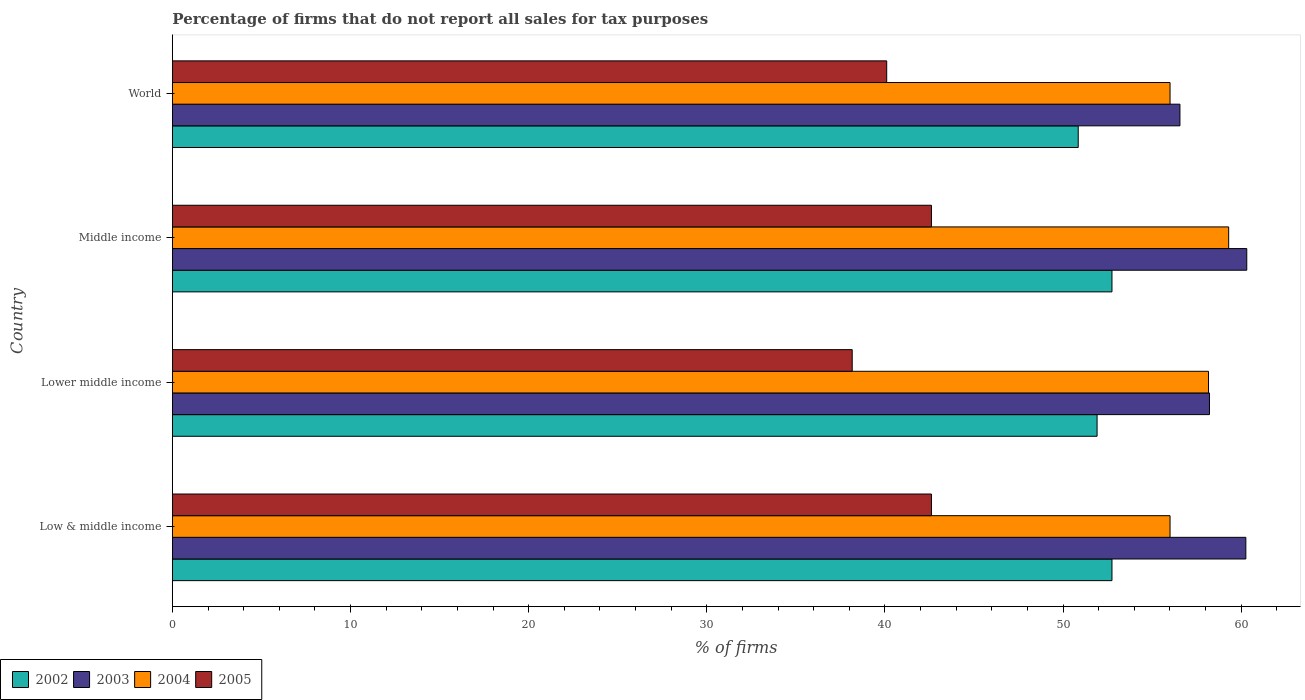Are the number of bars on each tick of the Y-axis equal?
Ensure brevity in your answer.  Yes. How many bars are there on the 2nd tick from the top?
Offer a very short reply. 4. In how many cases, is the number of bars for a given country not equal to the number of legend labels?
Provide a succinct answer. 0. What is the percentage of firms that do not report all sales for tax purposes in 2003 in Middle income?
Make the answer very short. 60.31. Across all countries, what is the maximum percentage of firms that do not report all sales for tax purposes in 2004?
Give a very brief answer. 59.3. Across all countries, what is the minimum percentage of firms that do not report all sales for tax purposes in 2003?
Keep it short and to the point. 56.56. In which country was the percentage of firms that do not report all sales for tax purposes in 2003 maximum?
Provide a short and direct response. Middle income. In which country was the percentage of firms that do not report all sales for tax purposes in 2003 minimum?
Offer a terse response. World. What is the total percentage of firms that do not report all sales for tax purposes in 2002 in the graph?
Keep it short and to the point. 208.25. What is the difference between the percentage of firms that do not report all sales for tax purposes in 2005 in Low & middle income and that in Lower middle income?
Make the answer very short. 4.45. What is the difference between the percentage of firms that do not report all sales for tax purposes in 2004 in Middle income and the percentage of firms that do not report all sales for tax purposes in 2003 in World?
Keep it short and to the point. 2.74. What is the average percentage of firms that do not report all sales for tax purposes in 2004 per country?
Your answer should be compact. 57.37. What is the difference between the percentage of firms that do not report all sales for tax purposes in 2003 and percentage of firms that do not report all sales for tax purposes in 2002 in Lower middle income?
Offer a very short reply. 6.31. In how many countries, is the percentage of firms that do not report all sales for tax purposes in 2004 greater than 34 %?
Give a very brief answer. 4. What is the ratio of the percentage of firms that do not report all sales for tax purposes in 2003 in Lower middle income to that in World?
Give a very brief answer. 1.03. Is the percentage of firms that do not report all sales for tax purposes in 2003 in Lower middle income less than that in World?
Your response must be concise. No. Is the difference between the percentage of firms that do not report all sales for tax purposes in 2003 in Low & middle income and Middle income greater than the difference between the percentage of firms that do not report all sales for tax purposes in 2002 in Low & middle income and Middle income?
Provide a succinct answer. No. What is the difference between the highest and the second highest percentage of firms that do not report all sales for tax purposes in 2005?
Offer a very short reply. 0. What is the difference between the highest and the lowest percentage of firms that do not report all sales for tax purposes in 2004?
Keep it short and to the point. 3.29. Is it the case that in every country, the sum of the percentage of firms that do not report all sales for tax purposes in 2004 and percentage of firms that do not report all sales for tax purposes in 2005 is greater than the sum of percentage of firms that do not report all sales for tax purposes in 2002 and percentage of firms that do not report all sales for tax purposes in 2003?
Make the answer very short. No. What does the 3rd bar from the top in Low & middle income represents?
Keep it short and to the point. 2003. Is it the case that in every country, the sum of the percentage of firms that do not report all sales for tax purposes in 2005 and percentage of firms that do not report all sales for tax purposes in 2004 is greater than the percentage of firms that do not report all sales for tax purposes in 2002?
Ensure brevity in your answer.  Yes. How many countries are there in the graph?
Your answer should be compact. 4. How many legend labels are there?
Keep it short and to the point. 4. What is the title of the graph?
Your answer should be compact. Percentage of firms that do not report all sales for tax purposes. Does "1998" appear as one of the legend labels in the graph?
Give a very brief answer. No. What is the label or title of the X-axis?
Offer a terse response. % of firms. What is the % of firms in 2002 in Low & middle income?
Ensure brevity in your answer.  52.75. What is the % of firms in 2003 in Low & middle income?
Your answer should be very brief. 60.26. What is the % of firms in 2004 in Low & middle income?
Ensure brevity in your answer.  56.01. What is the % of firms in 2005 in Low & middle income?
Offer a very short reply. 42.61. What is the % of firms of 2002 in Lower middle income?
Provide a short and direct response. 51.91. What is the % of firms of 2003 in Lower middle income?
Your answer should be very brief. 58.22. What is the % of firms in 2004 in Lower middle income?
Offer a terse response. 58.16. What is the % of firms in 2005 in Lower middle income?
Make the answer very short. 38.16. What is the % of firms of 2002 in Middle income?
Offer a very short reply. 52.75. What is the % of firms of 2003 in Middle income?
Give a very brief answer. 60.31. What is the % of firms in 2004 in Middle income?
Provide a succinct answer. 59.3. What is the % of firms in 2005 in Middle income?
Your answer should be very brief. 42.61. What is the % of firms of 2002 in World?
Offer a very short reply. 50.85. What is the % of firms of 2003 in World?
Give a very brief answer. 56.56. What is the % of firms in 2004 in World?
Your answer should be compact. 56.01. What is the % of firms of 2005 in World?
Your answer should be compact. 40.1. Across all countries, what is the maximum % of firms in 2002?
Your response must be concise. 52.75. Across all countries, what is the maximum % of firms in 2003?
Ensure brevity in your answer.  60.31. Across all countries, what is the maximum % of firms in 2004?
Your response must be concise. 59.3. Across all countries, what is the maximum % of firms of 2005?
Offer a very short reply. 42.61. Across all countries, what is the minimum % of firms in 2002?
Provide a short and direct response. 50.85. Across all countries, what is the minimum % of firms of 2003?
Offer a terse response. 56.56. Across all countries, what is the minimum % of firms of 2004?
Provide a short and direct response. 56.01. Across all countries, what is the minimum % of firms of 2005?
Your answer should be compact. 38.16. What is the total % of firms of 2002 in the graph?
Make the answer very short. 208.25. What is the total % of firms of 2003 in the graph?
Your answer should be compact. 235.35. What is the total % of firms in 2004 in the graph?
Your answer should be compact. 229.47. What is the total % of firms in 2005 in the graph?
Your response must be concise. 163.48. What is the difference between the % of firms of 2002 in Low & middle income and that in Lower middle income?
Your response must be concise. 0.84. What is the difference between the % of firms in 2003 in Low & middle income and that in Lower middle income?
Give a very brief answer. 2.04. What is the difference between the % of firms of 2004 in Low & middle income and that in Lower middle income?
Your answer should be compact. -2.16. What is the difference between the % of firms in 2005 in Low & middle income and that in Lower middle income?
Ensure brevity in your answer.  4.45. What is the difference between the % of firms of 2002 in Low & middle income and that in Middle income?
Your response must be concise. 0. What is the difference between the % of firms of 2003 in Low & middle income and that in Middle income?
Your response must be concise. -0.05. What is the difference between the % of firms in 2004 in Low & middle income and that in Middle income?
Give a very brief answer. -3.29. What is the difference between the % of firms in 2005 in Low & middle income and that in Middle income?
Provide a succinct answer. 0. What is the difference between the % of firms in 2002 in Low & middle income and that in World?
Ensure brevity in your answer.  1.89. What is the difference between the % of firms in 2003 in Low & middle income and that in World?
Ensure brevity in your answer.  3.7. What is the difference between the % of firms in 2004 in Low & middle income and that in World?
Your response must be concise. 0. What is the difference between the % of firms in 2005 in Low & middle income and that in World?
Ensure brevity in your answer.  2.51. What is the difference between the % of firms of 2002 in Lower middle income and that in Middle income?
Provide a succinct answer. -0.84. What is the difference between the % of firms of 2003 in Lower middle income and that in Middle income?
Your answer should be very brief. -2.09. What is the difference between the % of firms of 2004 in Lower middle income and that in Middle income?
Your answer should be very brief. -1.13. What is the difference between the % of firms in 2005 in Lower middle income and that in Middle income?
Offer a very short reply. -4.45. What is the difference between the % of firms in 2002 in Lower middle income and that in World?
Provide a succinct answer. 1.06. What is the difference between the % of firms of 2003 in Lower middle income and that in World?
Your answer should be compact. 1.66. What is the difference between the % of firms of 2004 in Lower middle income and that in World?
Offer a very short reply. 2.16. What is the difference between the % of firms of 2005 in Lower middle income and that in World?
Offer a very short reply. -1.94. What is the difference between the % of firms of 2002 in Middle income and that in World?
Give a very brief answer. 1.89. What is the difference between the % of firms in 2003 in Middle income and that in World?
Provide a short and direct response. 3.75. What is the difference between the % of firms in 2004 in Middle income and that in World?
Keep it short and to the point. 3.29. What is the difference between the % of firms in 2005 in Middle income and that in World?
Ensure brevity in your answer.  2.51. What is the difference between the % of firms in 2002 in Low & middle income and the % of firms in 2003 in Lower middle income?
Your response must be concise. -5.47. What is the difference between the % of firms of 2002 in Low & middle income and the % of firms of 2004 in Lower middle income?
Your answer should be very brief. -5.42. What is the difference between the % of firms of 2002 in Low & middle income and the % of firms of 2005 in Lower middle income?
Make the answer very short. 14.58. What is the difference between the % of firms in 2003 in Low & middle income and the % of firms in 2004 in Lower middle income?
Your answer should be very brief. 2.1. What is the difference between the % of firms in 2003 in Low & middle income and the % of firms in 2005 in Lower middle income?
Provide a short and direct response. 22.1. What is the difference between the % of firms in 2004 in Low & middle income and the % of firms in 2005 in Lower middle income?
Provide a succinct answer. 17.84. What is the difference between the % of firms in 2002 in Low & middle income and the % of firms in 2003 in Middle income?
Offer a terse response. -7.57. What is the difference between the % of firms in 2002 in Low & middle income and the % of firms in 2004 in Middle income?
Your answer should be compact. -6.55. What is the difference between the % of firms in 2002 in Low & middle income and the % of firms in 2005 in Middle income?
Provide a succinct answer. 10.13. What is the difference between the % of firms of 2003 in Low & middle income and the % of firms of 2004 in Middle income?
Provide a succinct answer. 0.96. What is the difference between the % of firms of 2003 in Low & middle income and the % of firms of 2005 in Middle income?
Your response must be concise. 17.65. What is the difference between the % of firms of 2004 in Low & middle income and the % of firms of 2005 in Middle income?
Your response must be concise. 13.39. What is the difference between the % of firms of 2002 in Low & middle income and the % of firms of 2003 in World?
Your answer should be compact. -3.81. What is the difference between the % of firms in 2002 in Low & middle income and the % of firms in 2004 in World?
Your answer should be compact. -3.26. What is the difference between the % of firms in 2002 in Low & middle income and the % of firms in 2005 in World?
Make the answer very short. 12.65. What is the difference between the % of firms of 2003 in Low & middle income and the % of firms of 2004 in World?
Provide a short and direct response. 4.25. What is the difference between the % of firms in 2003 in Low & middle income and the % of firms in 2005 in World?
Offer a terse response. 20.16. What is the difference between the % of firms of 2004 in Low & middle income and the % of firms of 2005 in World?
Give a very brief answer. 15.91. What is the difference between the % of firms of 2002 in Lower middle income and the % of firms of 2003 in Middle income?
Your answer should be compact. -8.4. What is the difference between the % of firms of 2002 in Lower middle income and the % of firms of 2004 in Middle income?
Keep it short and to the point. -7.39. What is the difference between the % of firms of 2002 in Lower middle income and the % of firms of 2005 in Middle income?
Keep it short and to the point. 9.3. What is the difference between the % of firms in 2003 in Lower middle income and the % of firms in 2004 in Middle income?
Give a very brief answer. -1.08. What is the difference between the % of firms of 2003 in Lower middle income and the % of firms of 2005 in Middle income?
Provide a succinct answer. 15.61. What is the difference between the % of firms of 2004 in Lower middle income and the % of firms of 2005 in Middle income?
Ensure brevity in your answer.  15.55. What is the difference between the % of firms of 2002 in Lower middle income and the % of firms of 2003 in World?
Keep it short and to the point. -4.65. What is the difference between the % of firms of 2002 in Lower middle income and the % of firms of 2004 in World?
Offer a terse response. -4.1. What is the difference between the % of firms in 2002 in Lower middle income and the % of firms in 2005 in World?
Your response must be concise. 11.81. What is the difference between the % of firms of 2003 in Lower middle income and the % of firms of 2004 in World?
Ensure brevity in your answer.  2.21. What is the difference between the % of firms in 2003 in Lower middle income and the % of firms in 2005 in World?
Your response must be concise. 18.12. What is the difference between the % of firms in 2004 in Lower middle income and the % of firms in 2005 in World?
Ensure brevity in your answer.  18.07. What is the difference between the % of firms of 2002 in Middle income and the % of firms of 2003 in World?
Provide a short and direct response. -3.81. What is the difference between the % of firms of 2002 in Middle income and the % of firms of 2004 in World?
Keep it short and to the point. -3.26. What is the difference between the % of firms of 2002 in Middle income and the % of firms of 2005 in World?
Offer a very short reply. 12.65. What is the difference between the % of firms in 2003 in Middle income and the % of firms in 2004 in World?
Keep it short and to the point. 4.31. What is the difference between the % of firms in 2003 in Middle income and the % of firms in 2005 in World?
Ensure brevity in your answer.  20.21. What is the difference between the % of firms in 2004 in Middle income and the % of firms in 2005 in World?
Offer a very short reply. 19.2. What is the average % of firms in 2002 per country?
Keep it short and to the point. 52.06. What is the average % of firms of 2003 per country?
Your answer should be very brief. 58.84. What is the average % of firms of 2004 per country?
Offer a very short reply. 57.37. What is the average % of firms of 2005 per country?
Provide a short and direct response. 40.87. What is the difference between the % of firms of 2002 and % of firms of 2003 in Low & middle income?
Offer a terse response. -7.51. What is the difference between the % of firms in 2002 and % of firms in 2004 in Low & middle income?
Your answer should be very brief. -3.26. What is the difference between the % of firms of 2002 and % of firms of 2005 in Low & middle income?
Make the answer very short. 10.13. What is the difference between the % of firms in 2003 and % of firms in 2004 in Low & middle income?
Make the answer very short. 4.25. What is the difference between the % of firms of 2003 and % of firms of 2005 in Low & middle income?
Offer a very short reply. 17.65. What is the difference between the % of firms in 2004 and % of firms in 2005 in Low & middle income?
Offer a very short reply. 13.39. What is the difference between the % of firms of 2002 and % of firms of 2003 in Lower middle income?
Your answer should be very brief. -6.31. What is the difference between the % of firms of 2002 and % of firms of 2004 in Lower middle income?
Ensure brevity in your answer.  -6.26. What is the difference between the % of firms in 2002 and % of firms in 2005 in Lower middle income?
Offer a terse response. 13.75. What is the difference between the % of firms in 2003 and % of firms in 2004 in Lower middle income?
Make the answer very short. 0.05. What is the difference between the % of firms in 2003 and % of firms in 2005 in Lower middle income?
Provide a succinct answer. 20.06. What is the difference between the % of firms of 2004 and % of firms of 2005 in Lower middle income?
Offer a very short reply. 20. What is the difference between the % of firms in 2002 and % of firms in 2003 in Middle income?
Your answer should be compact. -7.57. What is the difference between the % of firms of 2002 and % of firms of 2004 in Middle income?
Ensure brevity in your answer.  -6.55. What is the difference between the % of firms of 2002 and % of firms of 2005 in Middle income?
Your response must be concise. 10.13. What is the difference between the % of firms of 2003 and % of firms of 2004 in Middle income?
Give a very brief answer. 1.02. What is the difference between the % of firms in 2003 and % of firms in 2005 in Middle income?
Make the answer very short. 17.7. What is the difference between the % of firms in 2004 and % of firms in 2005 in Middle income?
Ensure brevity in your answer.  16.69. What is the difference between the % of firms in 2002 and % of firms in 2003 in World?
Keep it short and to the point. -5.71. What is the difference between the % of firms of 2002 and % of firms of 2004 in World?
Provide a short and direct response. -5.15. What is the difference between the % of firms of 2002 and % of firms of 2005 in World?
Offer a very short reply. 10.75. What is the difference between the % of firms of 2003 and % of firms of 2004 in World?
Give a very brief answer. 0.56. What is the difference between the % of firms in 2003 and % of firms in 2005 in World?
Keep it short and to the point. 16.46. What is the difference between the % of firms in 2004 and % of firms in 2005 in World?
Make the answer very short. 15.91. What is the ratio of the % of firms of 2002 in Low & middle income to that in Lower middle income?
Offer a very short reply. 1.02. What is the ratio of the % of firms in 2003 in Low & middle income to that in Lower middle income?
Give a very brief answer. 1.04. What is the ratio of the % of firms of 2004 in Low & middle income to that in Lower middle income?
Offer a very short reply. 0.96. What is the ratio of the % of firms of 2005 in Low & middle income to that in Lower middle income?
Your answer should be compact. 1.12. What is the ratio of the % of firms in 2004 in Low & middle income to that in Middle income?
Your answer should be compact. 0.94. What is the ratio of the % of firms of 2005 in Low & middle income to that in Middle income?
Keep it short and to the point. 1. What is the ratio of the % of firms of 2002 in Low & middle income to that in World?
Offer a terse response. 1.04. What is the ratio of the % of firms of 2003 in Low & middle income to that in World?
Your response must be concise. 1.07. What is the ratio of the % of firms of 2004 in Low & middle income to that in World?
Your answer should be compact. 1. What is the ratio of the % of firms of 2005 in Low & middle income to that in World?
Your answer should be compact. 1.06. What is the ratio of the % of firms in 2002 in Lower middle income to that in Middle income?
Keep it short and to the point. 0.98. What is the ratio of the % of firms of 2003 in Lower middle income to that in Middle income?
Offer a very short reply. 0.97. What is the ratio of the % of firms of 2004 in Lower middle income to that in Middle income?
Your answer should be compact. 0.98. What is the ratio of the % of firms of 2005 in Lower middle income to that in Middle income?
Provide a succinct answer. 0.9. What is the ratio of the % of firms in 2002 in Lower middle income to that in World?
Your answer should be very brief. 1.02. What is the ratio of the % of firms of 2003 in Lower middle income to that in World?
Provide a succinct answer. 1.03. What is the ratio of the % of firms of 2004 in Lower middle income to that in World?
Provide a short and direct response. 1.04. What is the ratio of the % of firms in 2005 in Lower middle income to that in World?
Your response must be concise. 0.95. What is the ratio of the % of firms of 2002 in Middle income to that in World?
Your answer should be very brief. 1.04. What is the ratio of the % of firms of 2003 in Middle income to that in World?
Your answer should be very brief. 1.07. What is the ratio of the % of firms of 2004 in Middle income to that in World?
Keep it short and to the point. 1.06. What is the ratio of the % of firms of 2005 in Middle income to that in World?
Ensure brevity in your answer.  1.06. What is the difference between the highest and the second highest % of firms in 2003?
Provide a succinct answer. 0.05. What is the difference between the highest and the second highest % of firms of 2004?
Give a very brief answer. 1.13. What is the difference between the highest and the lowest % of firms of 2002?
Make the answer very short. 1.89. What is the difference between the highest and the lowest % of firms of 2003?
Ensure brevity in your answer.  3.75. What is the difference between the highest and the lowest % of firms of 2004?
Provide a succinct answer. 3.29. What is the difference between the highest and the lowest % of firms in 2005?
Your answer should be compact. 4.45. 